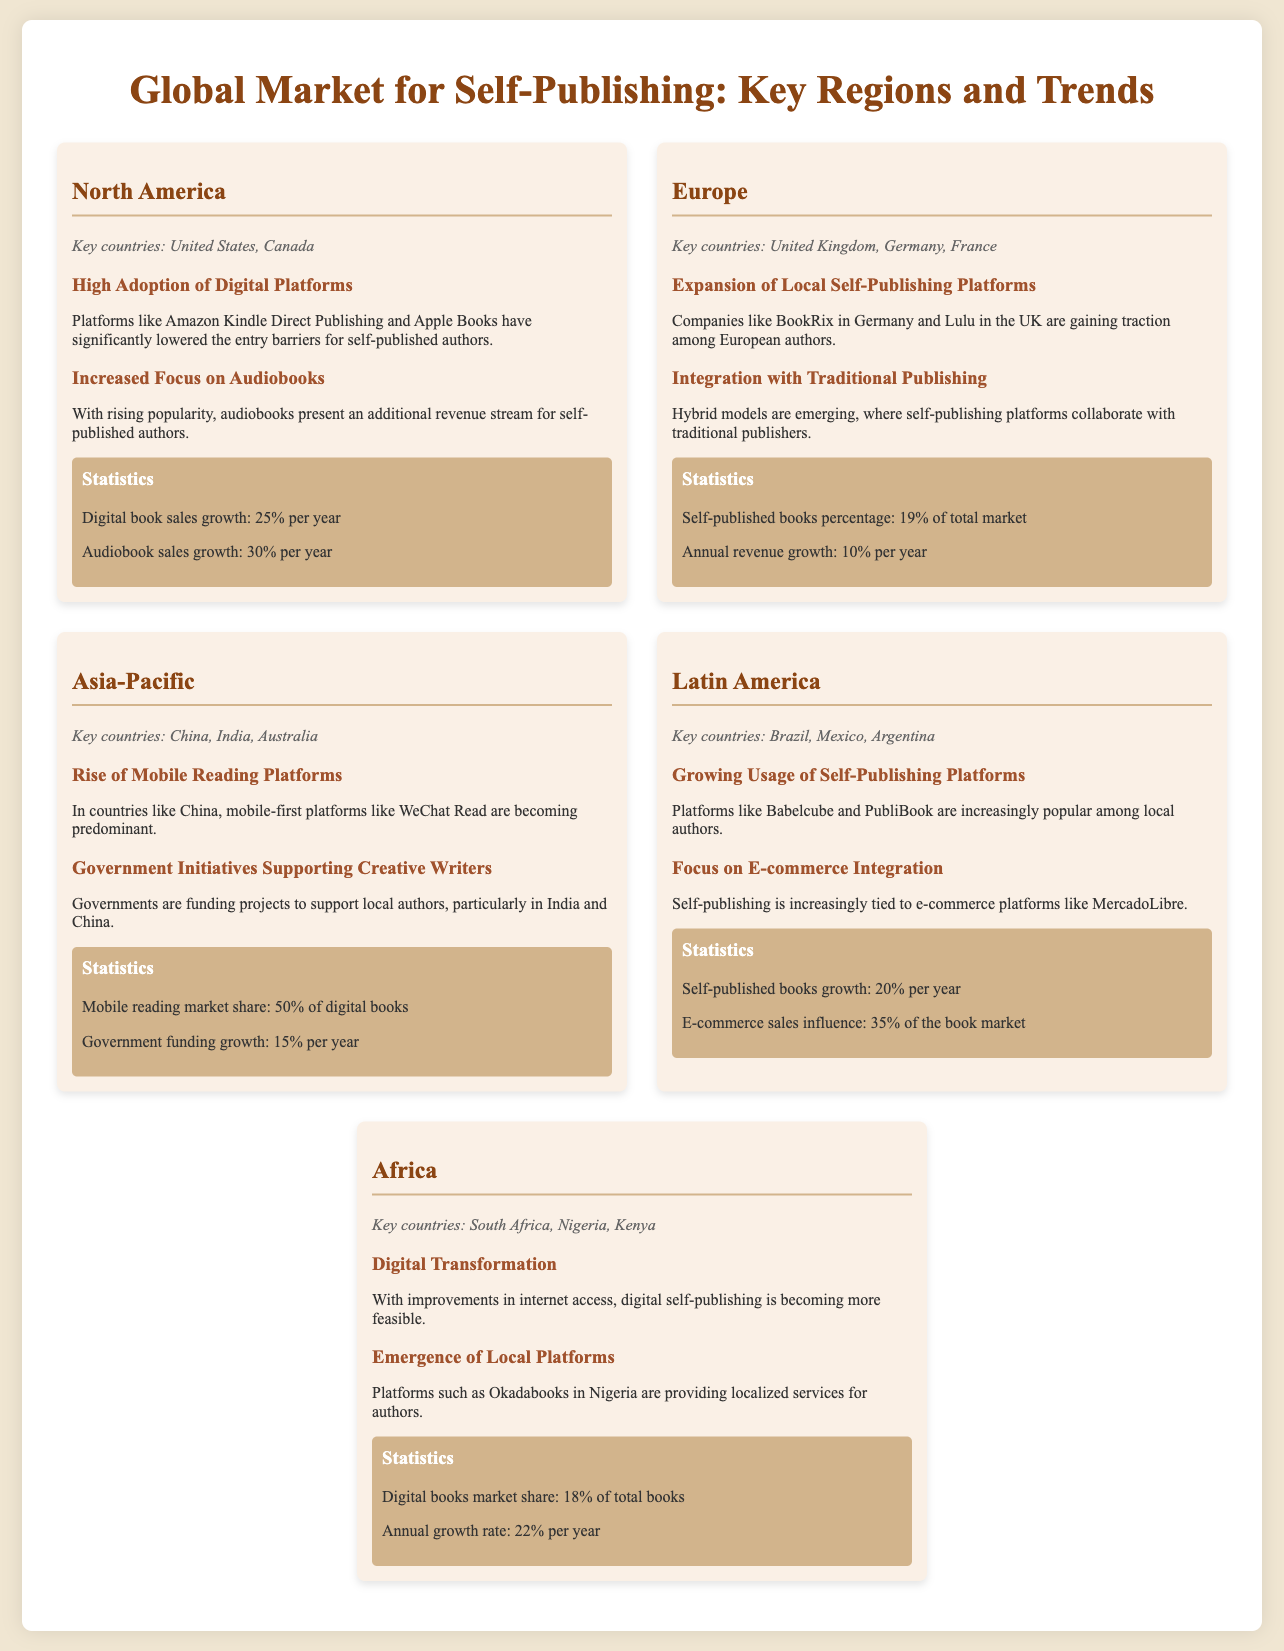What are the key countries in North America? The key countries listed under North America in the document are United States and Canada.
Answer: United States, Canada What is the annual revenue growth percentage in Europe? The document states that the annual revenue growth in Europe is 10% per year.
Answer: 10% per year Which region has a mobile reading market share of 50%? The Asia-Pacific region is noted for having a mobile reading market share of 50% of digital books.
Answer: Asia-Pacific What is the growth rate of self-published books in Latin America? The document mentions that the self-published books growth in Latin America is 20% per year.
Answer: 20% per year Which country is associated with the platform Okadabooks? According to the document, Okadabooks is associated with Nigeria.
Answer: Nigeria What trend is observed in Africa related to digital self-publishing? The document highlights the trend of digital transformation due to improvements in internet access in Africa.
Answer: Digital transformation What are the key countries in the Asia-Pacific region? The key countries listed for the Asia-Pacific region are China, India, and Australia.
Answer: China, India, Australia What percentage of the total market is made up of self-published books in Europe? The document states that self-published books comprise 19% of the total market in Europe.
Answer: 19% What platform is gaining traction in Germany? The document lists BookRix as a platform that is gaining traction in Germany.
Answer: BookRix 